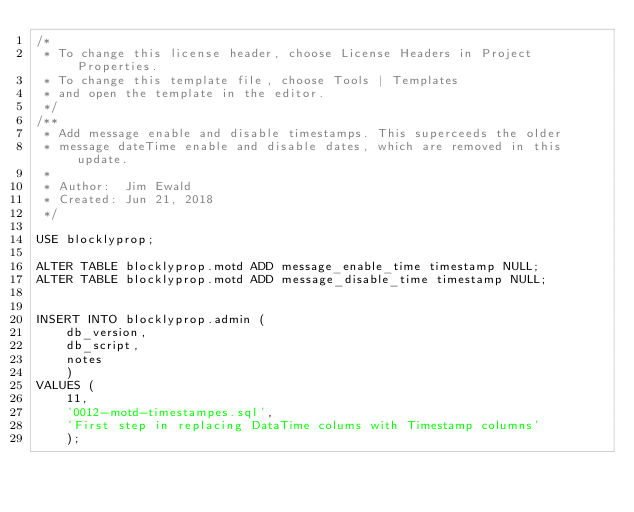Convert code to text. <code><loc_0><loc_0><loc_500><loc_500><_SQL_>/* 
 * To change this license header, choose License Headers in Project Properties.
 * To change this template file, choose Tools | Templates
 * and open the template in the editor.
 */
/**
 * Add message enable and disable timestamps. This superceeds the older
 * message dateTime enable and disable dates, which are removed in this update.
 *
 * Author:  Jim Ewald
 * Created: Jun 21, 2018
 */

USE blocklyprop;

ALTER TABLE blocklyprop.motd ADD message_enable_time timestamp NULL;
ALTER TABLE blocklyprop.motd ADD message_disable_time timestamp NULL;


INSERT INTO blocklyprop.admin (
    db_version, 
    db_script,
    notes
    )
VALUES (
    11,
    '0012-motd-timestampes.sql',
    'First step in replacing DataTime colums with Timestamp columns'
    );
</code> 